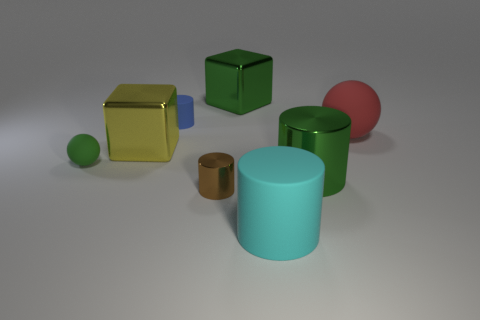There is a metallic block that is right of the small brown shiny cylinder; is its color the same as the matte sphere that is to the left of the small metal cylinder?
Your response must be concise. Yes. What number of shiny objects are red things or small blue spheres?
Your answer should be compact. 0. There is a large cyan rubber thing that is right of the tiny matte object that is to the left of the large yellow cube; what is its shape?
Provide a short and direct response. Cylinder. Is the cylinder behind the red matte sphere made of the same material as the sphere that is to the left of the brown thing?
Ensure brevity in your answer.  Yes. There is a big shiny thing that is behind the big red rubber object; how many balls are to the right of it?
Provide a succinct answer. 1. Does the big object that is in front of the large green metal cylinder have the same shape as the big metal object that is to the left of the tiny brown cylinder?
Your response must be concise. No. There is a object that is to the right of the large cyan rubber cylinder and in front of the tiny green rubber thing; what size is it?
Give a very brief answer. Large. The other shiny thing that is the same shape as the big yellow object is what color?
Keep it short and to the point. Green. The matte cylinder that is behind the sphere that is to the left of the brown metal cylinder is what color?
Give a very brief answer. Blue. The tiny metal thing is what shape?
Offer a terse response. Cylinder. 